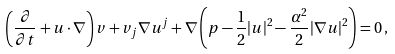Convert formula to latex. <formula><loc_0><loc_0><loc_500><loc_500>\left ( \frac { \partial } { \partial t } + u \cdot \nabla \right ) v + v _ { j } \nabla u ^ { j } + \nabla \left ( p - \frac { 1 } { 2 } | u | ^ { 2 } - \frac { \alpha ^ { 2 } } { 2 } | \nabla u | ^ { 2 } \right ) = 0 \, ,</formula> 